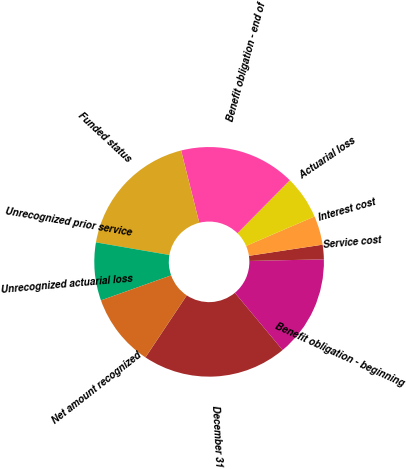Convert chart. <chart><loc_0><loc_0><loc_500><loc_500><pie_chart><fcel>December 31<fcel>Benefit obligation - beginning<fcel>Service cost<fcel>Interest cost<fcel>Actuarial loss<fcel>Benefit obligation - end of<fcel>Funded status<fcel>Unrecognized prior service<fcel>Unrecognized actuarial loss<fcel>Net amount recognized<nl><fcel>20.41%<fcel>14.29%<fcel>2.04%<fcel>4.08%<fcel>6.12%<fcel>16.33%<fcel>18.37%<fcel>0.0%<fcel>8.16%<fcel>10.2%<nl></chart> 